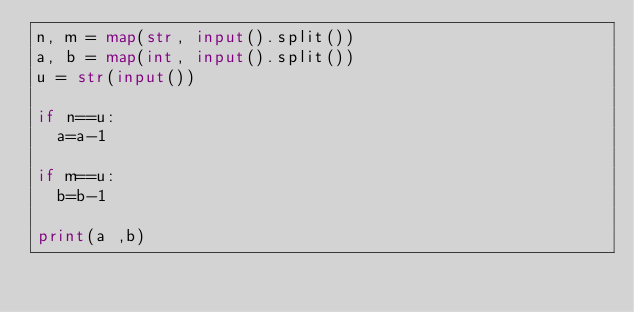<code> <loc_0><loc_0><loc_500><loc_500><_Python_>n, m = map(str, input().split())
a, b = map(int, input().split())
u = str(input())

if n==u:
  a=a-1
  
if m==u:
  b=b-1

print(a ,b)</code> 